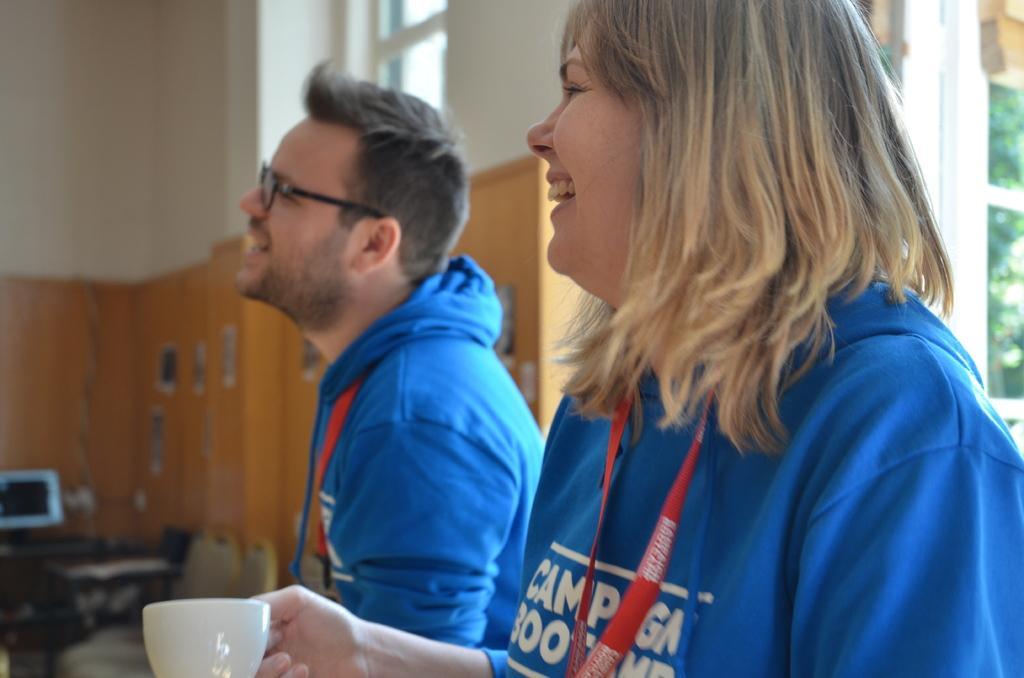Please provide a concise description of this image. In this picture there is a woman who is wearing blue t-shirt and holding a teacup. Beside her there is a man who is wearing spectacle and blue hoodie. On the right I can see the trees and sky through the window. On the left there is a laptop and other objects on the table, beside that I can see the chairs. At the top I can see the window. 